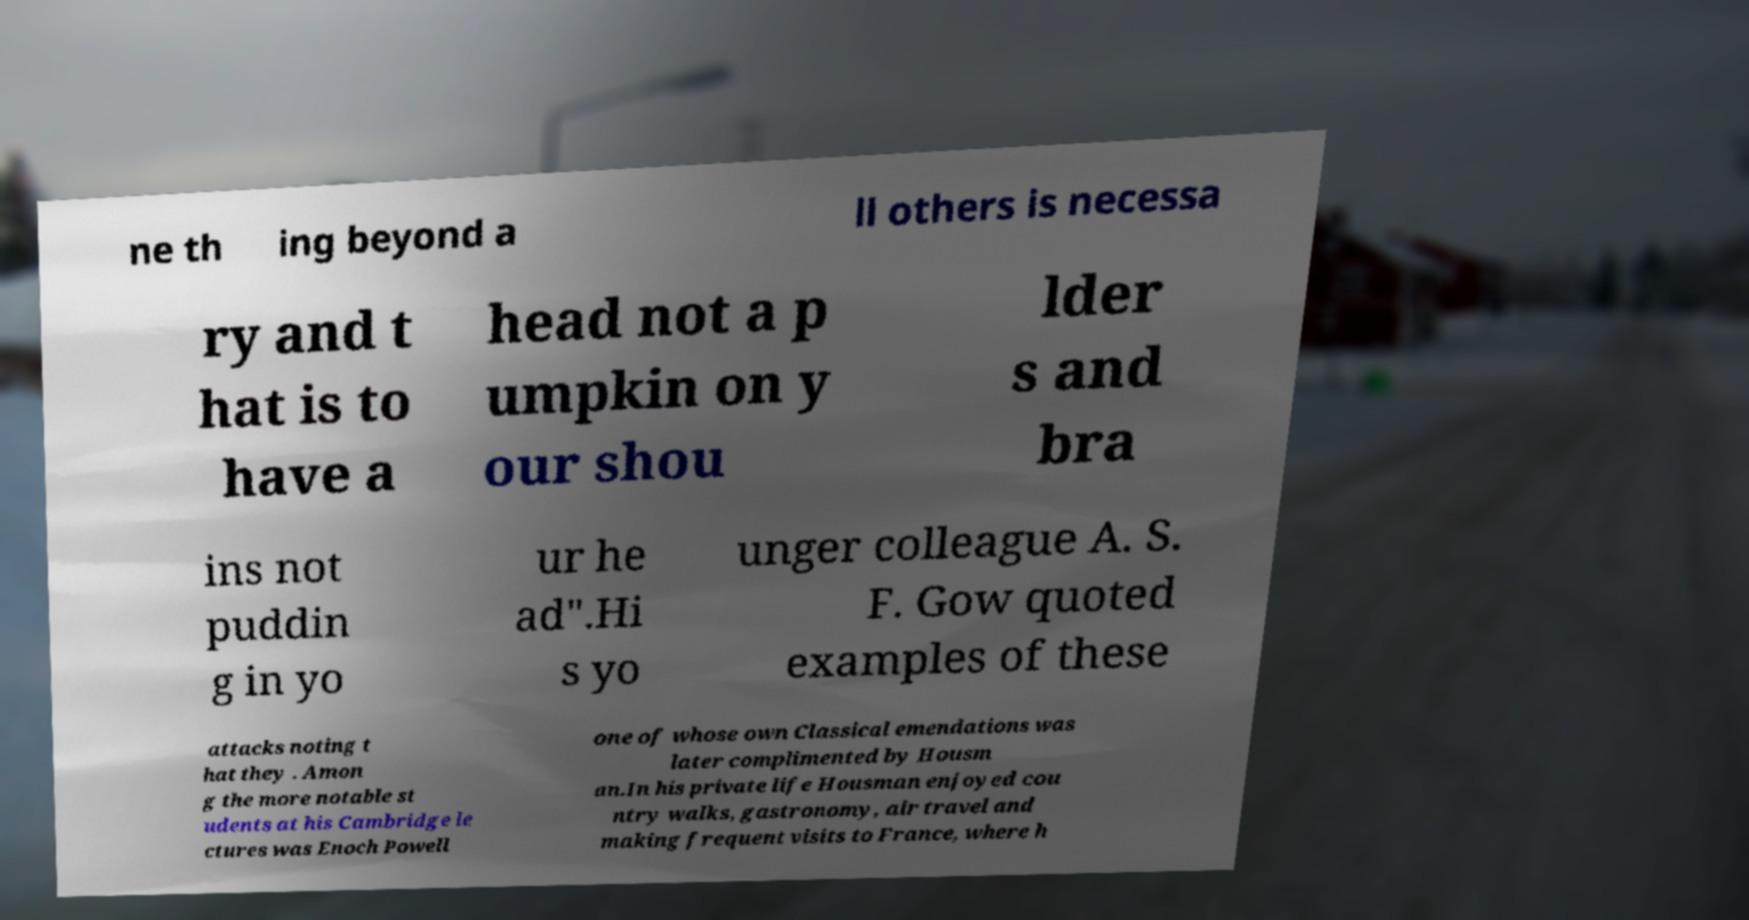Can you read and provide the text displayed in the image?This photo seems to have some interesting text. Can you extract and type it out for me? ne th ing beyond a ll others is necessa ry and t hat is to have a head not a p umpkin on y our shou lder s and bra ins not puddin g in yo ur he ad".Hi s yo unger colleague A. S. F. Gow quoted examples of these attacks noting t hat they . Amon g the more notable st udents at his Cambridge le ctures was Enoch Powell one of whose own Classical emendations was later complimented by Housm an.In his private life Housman enjoyed cou ntry walks, gastronomy, air travel and making frequent visits to France, where h 